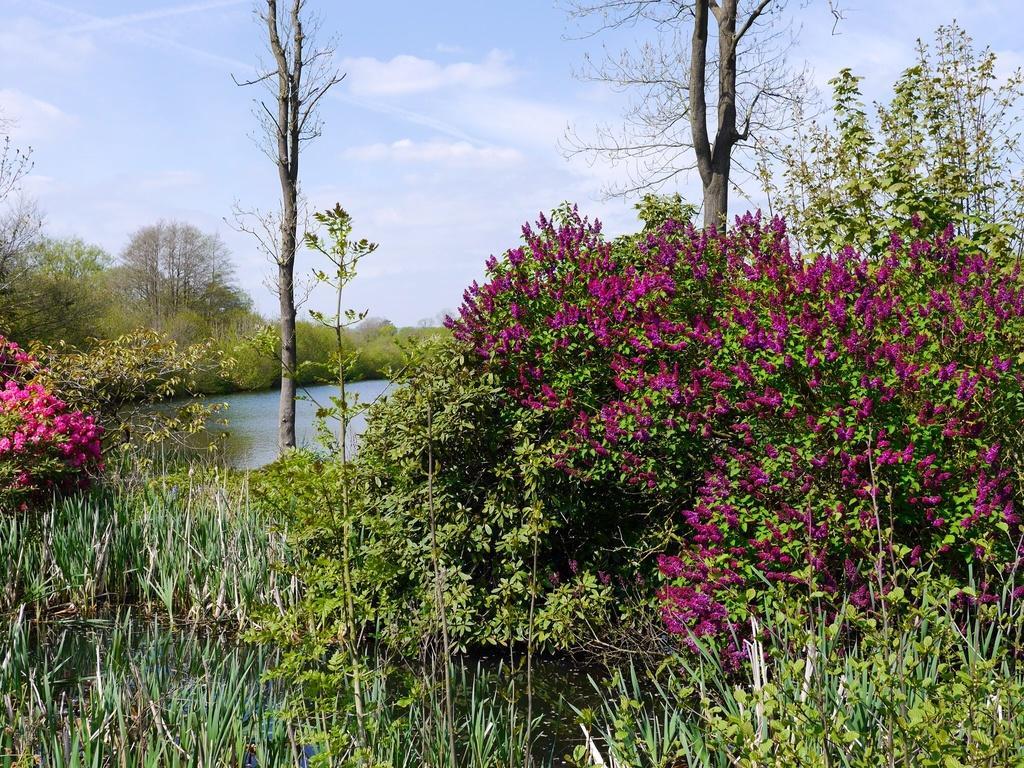In one or two sentences, can you explain what this image depicts? In this image there is grass, plants with flowers, water , trees, and in the background there is sky. 